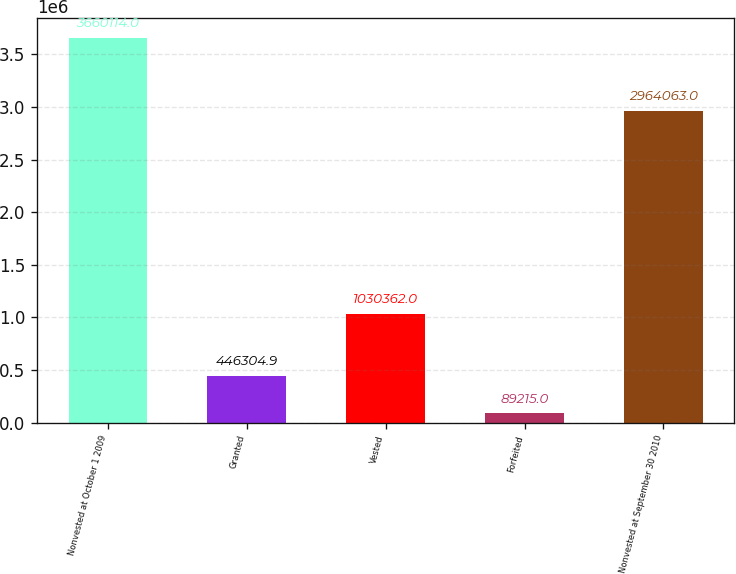<chart> <loc_0><loc_0><loc_500><loc_500><bar_chart><fcel>Nonvested at October 1 2009<fcel>Granted<fcel>Vested<fcel>Forfeited<fcel>Nonvested at September 30 2010<nl><fcel>3.66011e+06<fcel>446305<fcel>1.03036e+06<fcel>89215<fcel>2.96406e+06<nl></chart> 